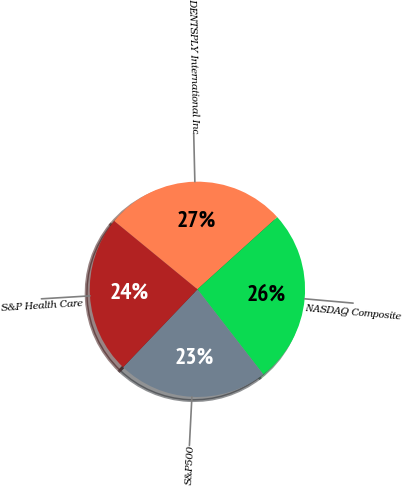Convert chart. <chart><loc_0><loc_0><loc_500><loc_500><pie_chart><fcel>DENTSPLY International Inc<fcel>NASDAQ Composite<fcel>S&P500<fcel>S&P Health Care<nl><fcel>27.36%<fcel>26.21%<fcel>22.61%<fcel>23.82%<nl></chart> 